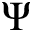Convert formula to latex. <formula><loc_0><loc_0><loc_500><loc_500>\Psi</formula> 